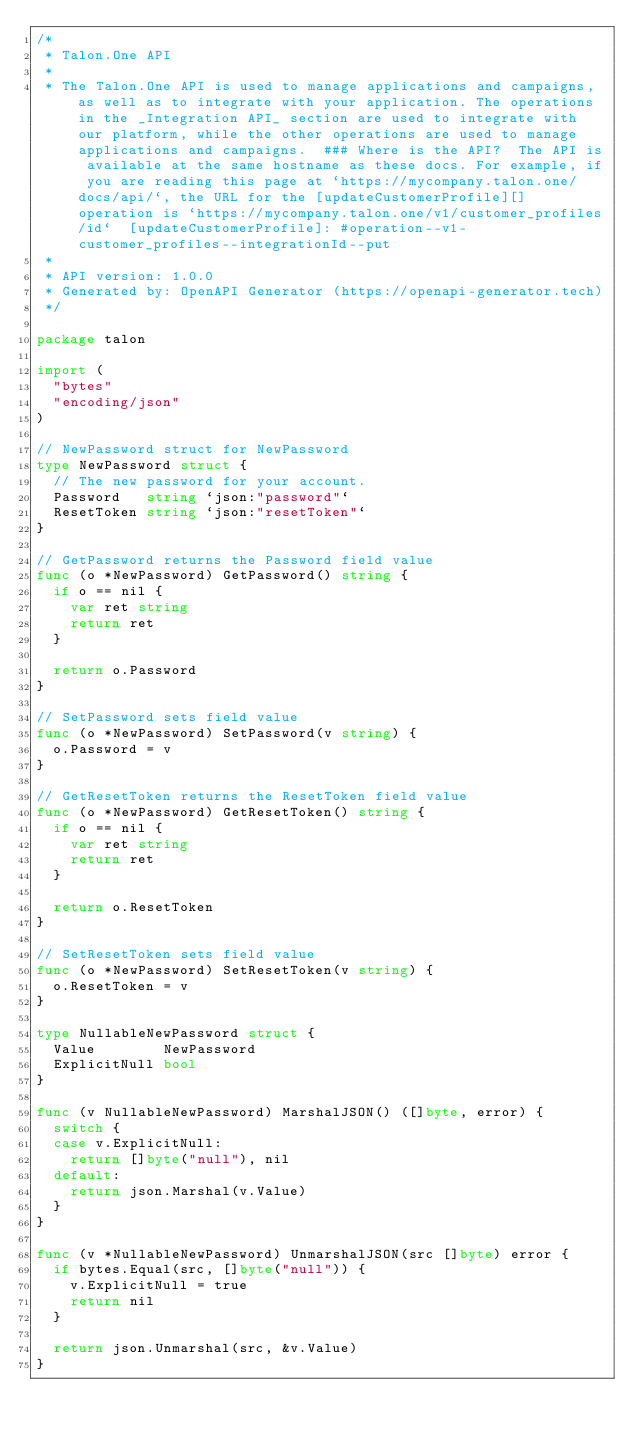<code> <loc_0><loc_0><loc_500><loc_500><_Go_>/*
 * Talon.One API
 *
 * The Talon.One API is used to manage applications and campaigns, as well as to integrate with your application. The operations in the _Integration API_ section are used to integrate with our platform, while the other operations are used to manage applications and campaigns.  ### Where is the API?  The API is available at the same hostname as these docs. For example, if you are reading this page at `https://mycompany.talon.one/docs/api/`, the URL for the [updateCustomerProfile][] operation is `https://mycompany.talon.one/v1/customer_profiles/id`  [updateCustomerProfile]: #operation--v1-customer_profiles--integrationId--put
 *
 * API version: 1.0.0
 * Generated by: OpenAPI Generator (https://openapi-generator.tech)
 */

package talon

import (
	"bytes"
	"encoding/json"
)

// NewPassword struct for NewPassword
type NewPassword struct {
	// The new password for your account.
	Password   string `json:"password"`
	ResetToken string `json:"resetToken"`
}

// GetPassword returns the Password field value
func (o *NewPassword) GetPassword() string {
	if o == nil {
		var ret string
		return ret
	}

	return o.Password
}

// SetPassword sets field value
func (o *NewPassword) SetPassword(v string) {
	o.Password = v
}

// GetResetToken returns the ResetToken field value
func (o *NewPassword) GetResetToken() string {
	if o == nil {
		var ret string
		return ret
	}

	return o.ResetToken
}

// SetResetToken sets field value
func (o *NewPassword) SetResetToken(v string) {
	o.ResetToken = v
}

type NullableNewPassword struct {
	Value        NewPassword
	ExplicitNull bool
}

func (v NullableNewPassword) MarshalJSON() ([]byte, error) {
	switch {
	case v.ExplicitNull:
		return []byte("null"), nil
	default:
		return json.Marshal(v.Value)
	}
}

func (v *NullableNewPassword) UnmarshalJSON(src []byte) error {
	if bytes.Equal(src, []byte("null")) {
		v.ExplicitNull = true
		return nil
	}

	return json.Unmarshal(src, &v.Value)
}
</code> 